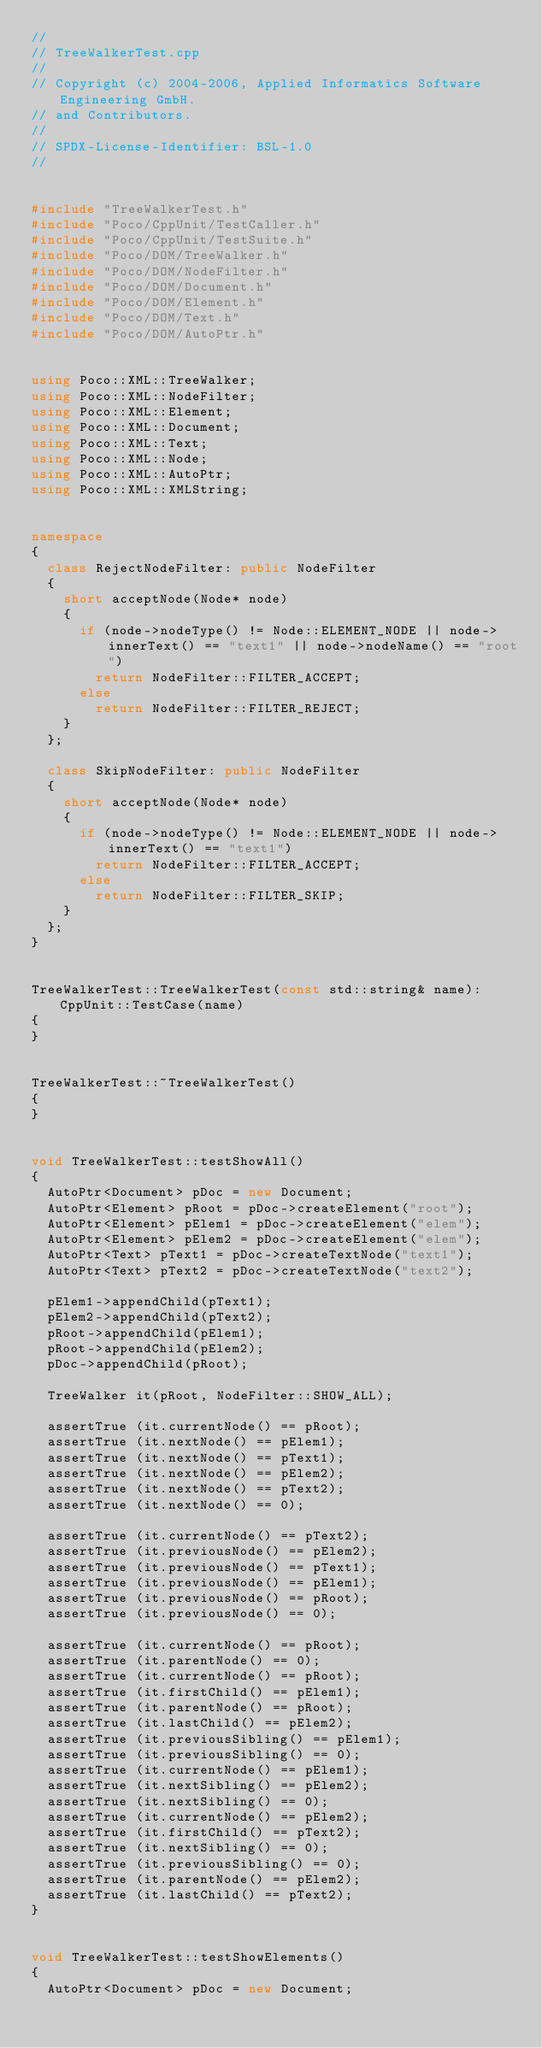Convert code to text. <code><loc_0><loc_0><loc_500><loc_500><_C++_>//
// TreeWalkerTest.cpp
//
// Copyright (c) 2004-2006, Applied Informatics Software Engineering GmbH.
// and Contributors.
//
// SPDX-License-Identifier:	BSL-1.0
//


#include "TreeWalkerTest.h"
#include "Poco/CppUnit/TestCaller.h"
#include "Poco/CppUnit/TestSuite.h"
#include "Poco/DOM/TreeWalker.h"
#include "Poco/DOM/NodeFilter.h"
#include "Poco/DOM/Document.h"
#include "Poco/DOM/Element.h"
#include "Poco/DOM/Text.h"
#include "Poco/DOM/AutoPtr.h"


using Poco::XML::TreeWalker;
using Poco::XML::NodeFilter;
using Poco::XML::Element;
using Poco::XML::Document;
using Poco::XML::Text;
using Poco::XML::Node;
using Poco::XML::AutoPtr;
using Poco::XML::XMLString;


namespace
{
	class RejectNodeFilter: public NodeFilter
	{
		short acceptNode(Node* node)
		{
			if (node->nodeType() != Node::ELEMENT_NODE || node->innerText() == "text1" || node->nodeName() == "root")
				return NodeFilter::FILTER_ACCEPT;
			else
				return NodeFilter::FILTER_REJECT;
		}
	};

	class SkipNodeFilter: public NodeFilter
	{
		short acceptNode(Node* node)
		{
			if (node->nodeType() != Node::ELEMENT_NODE || node->innerText() == "text1")
				return NodeFilter::FILTER_ACCEPT;
			else
				return NodeFilter::FILTER_SKIP;
		}
	};
}


TreeWalkerTest::TreeWalkerTest(const std::string& name): CppUnit::TestCase(name)
{
}


TreeWalkerTest::~TreeWalkerTest()
{
}


void TreeWalkerTest::testShowAll()
{
	AutoPtr<Document> pDoc = new Document;
	AutoPtr<Element> pRoot = pDoc->createElement("root");
	AutoPtr<Element> pElem1 = pDoc->createElement("elem");
	AutoPtr<Element> pElem2 = pDoc->createElement("elem");
	AutoPtr<Text> pText1 = pDoc->createTextNode("text1");
	AutoPtr<Text> pText2 = pDoc->createTextNode("text2");
	
	pElem1->appendChild(pText1);
	pElem2->appendChild(pText2);
	pRoot->appendChild(pElem1);
	pRoot->appendChild(pElem2);
	pDoc->appendChild(pRoot);
	
	TreeWalker it(pRoot, NodeFilter::SHOW_ALL);
	
	assertTrue (it.currentNode() == pRoot);
	assertTrue (it.nextNode() == pElem1);
	assertTrue (it.nextNode() == pText1);
	assertTrue (it.nextNode() == pElem2);
	assertTrue (it.nextNode() == pText2);
	assertTrue (it.nextNode() == 0);
	
	assertTrue (it.currentNode() == pText2);
	assertTrue (it.previousNode() == pElem2);
	assertTrue (it.previousNode() == pText1);
	assertTrue (it.previousNode() == pElem1);
	assertTrue (it.previousNode() == pRoot);
	assertTrue (it.previousNode() == 0);
	
	assertTrue (it.currentNode() == pRoot);
	assertTrue (it.parentNode() == 0);
	assertTrue (it.currentNode() == pRoot);
	assertTrue (it.firstChild() == pElem1);
	assertTrue (it.parentNode() == pRoot);
	assertTrue (it.lastChild() == pElem2);
	assertTrue (it.previousSibling() == pElem1);
	assertTrue (it.previousSibling() == 0);
	assertTrue (it.currentNode() == pElem1);
	assertTrue (it.nextSibling() == pElem2);
	assertTrue (it.nextSibling() == 0);
	assertTrue (it.currentNode() == pElem2);
	assertTrue (it.firstChild() == pText2);
	assertTrue (it.nextSibling() == 0);
	assertTrue (it.previousSibling() == 0);
	assertTrue (it.parentNode() == pElem2);
	assertTrue (it.lastChild() == pText2);
}


void TreeWalkerTest::testShowElements()
{
	AutoPtr<Document> pDoc = new Document;</code> 